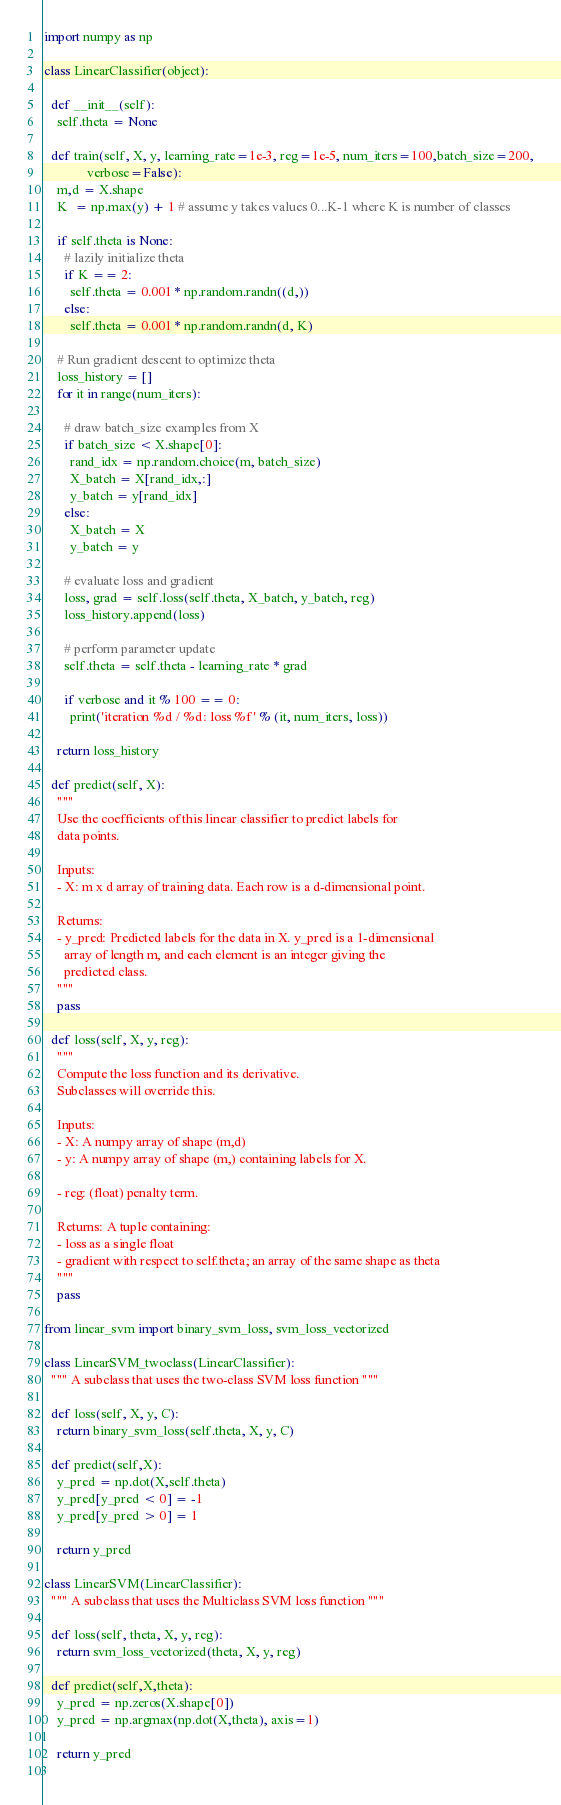Convert code to text. <code><loc_0><loc_0><loc_500><loc_500><_Python_>import numpy as np

class LinearClassifier(object):

  def __init__(self):
    self.theta = None

  def train(self, X, y, learning_rate=1e-3, reg=1e-5, num_iters=100,batch_size=200,
             verbose=False):
    m,d = X.shape
    K  = np.max(y) + 1 # assume y takes values 0...K-1 where K is number of classes

    if self.theta is None:
      # lazily initialize theta
      if K == 2:
        self.theta = 0.001 * np.random.randn((d,))
      else:
        self.theta = 0.001 * np.random.randn(d, K)

    # Run gradient descent to optimize theta
    loss_history = []
    for it in range(num_iters):

      # draw batch_size examples from X
      if batch_size < X.shape[0]:
        rand_idx = np.random.choice(m, batch_size)
        X_batch = X[rand_idx,:]
        y_batch = y[rand_idx]
      else:
        X_batch = X
        y_batch = y

      # evaluate loss and gradient
      loss, grad = self.loss(self.theta, X_batch, y_batch, reg)
      loss_history.append(loss)

      # perform parameter update
      self.theta = self.theta - learning_rate * grad

      if verbose and it % 100 == 0:
        print('iteration %d / %d: loss %f' % (it, num_iters, loss))

    return loss_history

  def predict(self, X):
    """
    Use the coefficients of this linear classifier to predict labels for
    data points.

    Inputs:
    - X: m x d array of training data. Each row is a d-dimensional point.

    Returns:
    - y_pred: Predicted labels for the data in X. y_pred is a 1-dimensional
      array of length m, and each element is an integer giving the
      predicted class.
    """
    pass
  
  def loss(self, X, y, reg):
    """
    Compute the loss function and its derivative. 
    Subclasses will override this.

    Inputs:
    - X: A numpy array of shape (m,d)
    - y: A numpy array of shape (m,) containing labels for X.

    - reg: (float) penalty term.

    Returns: A tuple containing:
    - loss as a single float
    - gradient with respect to self.theta; an array of the same shape as theta
    """
    pass

from linear_svm import binary_svm_loss, svm_loss_vectorized

class LinearSVM_twoclass(LinearClassifier):
  """ A subclass that uses the two-class SVM loss function """

  def loss(self, X, y, C):
    return binary_svm_loss(self.theta, X, y, C)

  def predict(self,X):
    y_pred = np.dot(X,self.theta)
    y_pred[y_pred < 0] = -1
    y_pred[y_pred > 0] = 1

    return y_pred 

class LinearSVM(LinearClassifier):
  """ A subclass that uses the Multiclass SVM loss function """

  def loss(self, theta, X, y, reg):
    return svm_loss_vectorized(theta, X, y, reg)

  def predict(self,X,theta):
    y_pred = np.zeros(X.shape[0])
    y_pred = np.argmax(np.dot(X,theta), axis=1)
    
    return y_pred
    
</code> 